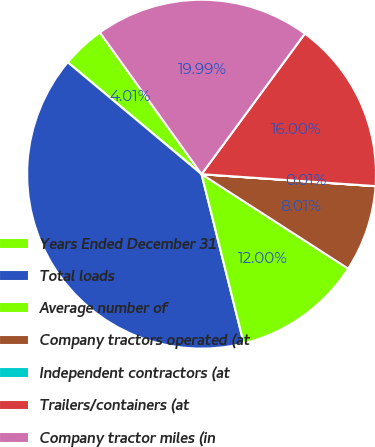<chart> <loc_0><loc_0><loc_500><loc_500><pie_chart><fcel>Years Ended December 31<fcel>Total loads<fcel>Average number of<fcel>Company tractors operated (at<fcel>Independent contractors (at<fcel>Trailers/containers (at<fcel>Company tractor miles (in<nl><fcel>4.01%<fcel>39.97%<fcel>12.0%<fcel>8.01%<fcel>0.01%<fcel>16.0%<fcel>19.99%<nl></chart> 